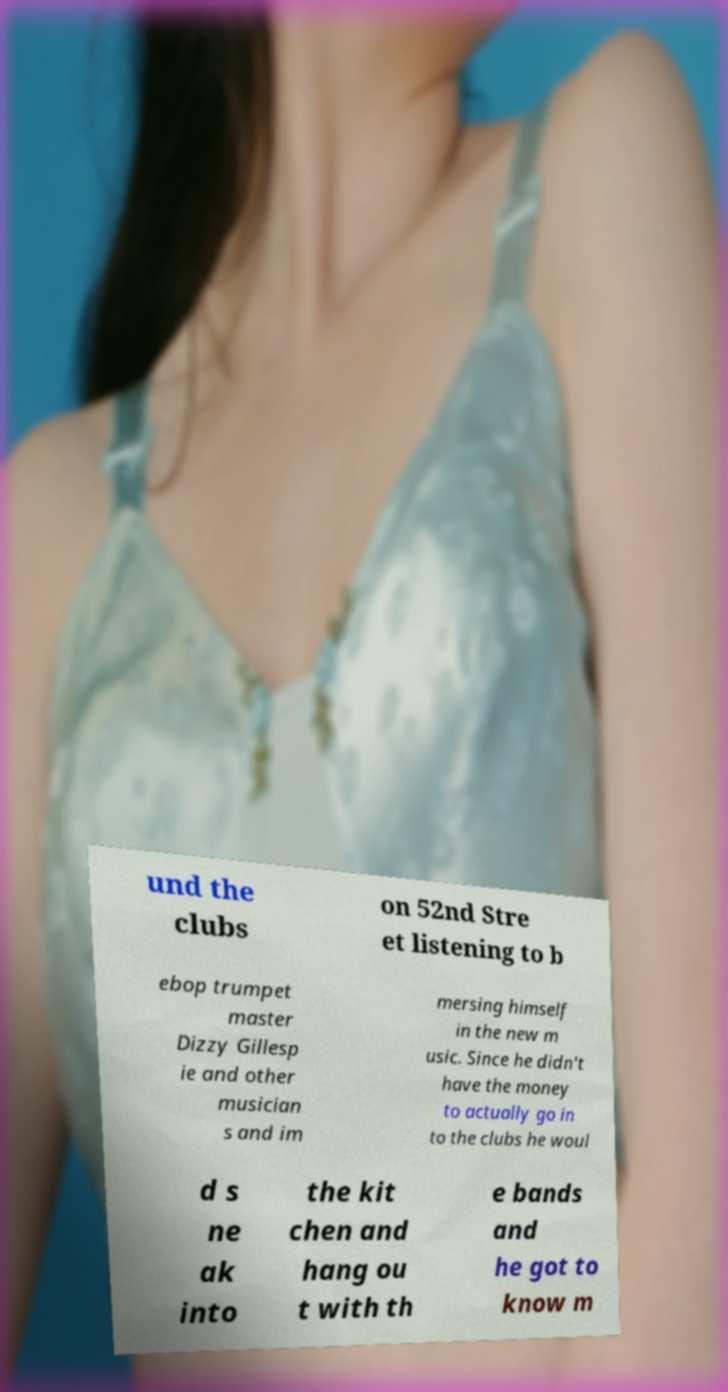Can you read and provide the text displayed in the image?This photo seems to have some interesting text. Can you extract and type it out for me? und the clubs on 52nd Stre et listening to b ebop trumpet master Dizzy Gillesp ie and other musician s and im mersing himself in the new m usic. Since he didn't have the money to actually go in to the clubs he woul d s ne ak into the kit chen and hang ou t with th e bands and he got to know m 